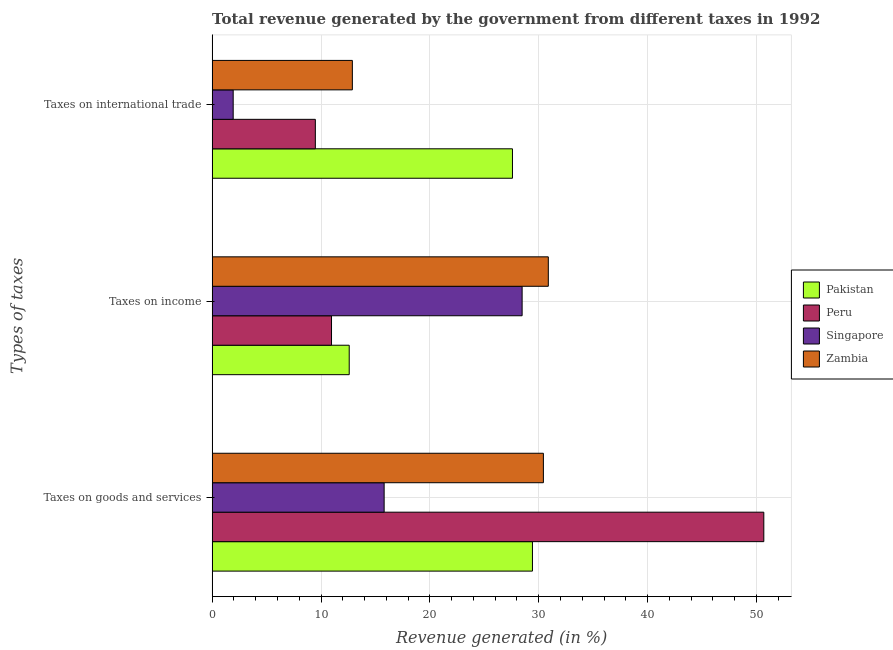How many groups of bars are there?
Your answer should be compact. 3. How many bars are there on the 1st tick from the top?
Offer a very short reply. 4. How many bars are there on the 2nd tick from the bottom?
Provide a succinct answer. 4. What is the label of the 3rd group of bars from the top?
Offer a very short reply. Taxes on goods and services. What is the percentage of revenue generated by tax on international trade in Peru?
Provide a succinct answer. 9.48. Across all countries, what is the maximum percentage of revenue generated by taxes on goods and services?
Keep it short and to the point. 50.67. Across all countries, what is the minimum percentage of revenue generated by taxes on goods and services?
Ensure brevity in your answer.  15.8. In which country was the percentage of revenue generated by taxes on goods and services minimum?
Offer a terse response. Singapore. What is the total percentage of revenue generated by tax on international trade in the graph?
Provide a short and direct response. 51.88. What is the difference between the percentage of revenue generated by taxes on income in Peru and that in Singapore?
Your answer should be compact. -17.51. What is the difference between the percentage of revenue generated by taxes on goods and services in Pakistan and the percentage of revenue generated by tax on international trade in Zambia?
Ensure brevity in your answer.  16.54. What is the average percentage of revenue generated by taxes on income per country?
Offer a very short reply. 20.73. What is the difference between the percentage of revenue generated by tax on international trade and percentage of revenue generated by taxes on goods and services in Singapore?
Your response must be concise. -13.87. What is the ratio of the percentage of revenue generated by taxes on goods and services in Singapore to that in Pakistan?
Provide a short and direct response. 0.54. What is the difference between the highest and the second highest percentage of revenue generated by taxes on goods and services?
Ensure brevity in your answer.  20.25. What is the difference between the highest and the lowest percentage of revenue generated by taxes on goods and services?
Keep it short and to the point. 34.87. In how many countries, is the percentage of revenue generated by taxes on goods and services greater than the average percentage of revenue generated by taxes on goods and services taken over all countries?
Offer a very short reply. 1. Is the sum of the percentage of revenue generated by tax on international trade in Peru and Zambia greater than the maximum percentage of revenue generated by taxes on income across all countries?
Give a very brief answer. No. Are all the bars in the graph horizontal?
Offer a terse response. Yes. Are the values on the major ticks of X-axis written in scientific E-notation?
Offer a very short reply. No. Does the graph contain any zero values?
Ensure brevity in your answer.  No. Does the graph contain grids?
Ensure brevity in your answer.  Yes. How many legend labels are there?
Your answer should be compact. 4. How are the legend labels stacked?
Provide a short and direct response. Vertical. What is the title of the graph?
Keep it short and to the point. Total revenue generated by the government from different taxes in 1992. Does "Ecuador" appear as one of the legend labels in the graph?
Make the answer very short. No. What is the label or title of the X-axis?
Provide a succinct answer. Revenue generated (in %). What is the label or title of the Y-axis?
Your answer should be compact. Types of taxes. What is the Revenue generated (in %) in Pakistan in Taxes on goods and services?
Your answer should be compact. 29.42. What is the Revenue generated (in %) of Peru in Taxes on goods and services?
Your response must be concise. 50.67. What is the Revenue generated (in %) in Singapore in Taxes on goods and services?
Provide a succinct answer. 15.8. What is the Revenue generated (in %) in Zambia in Taxes on goods and services?
Ensure brevity in your answer.  30.43. What is the Revenue generated (in %) in Pakistan in Taxes on income?
Make the answer very short. 12.59. What is the Revenue generated (in %) in Peru in Taxes on income?
Your answer should be very brief. 10.97. What is the Revenue generated (in %) of Singapore in Taxes on income?
Offer a terse response. 28.47. What is the Revenue generated (in %) of Zambia in Taxes on income?
Provide a short and direct response. 30.88. What is the Revenue generated (in %) in Pakistan in Taxes on international trade?
Provide a short and direct response. 27.59. What is the Revenue generated (in %) of Peru in Taxes on international trade?
Provide a short and direct response. 9.48. What is the Revenue generated (in %) in Singapore in Taxes on international trade?
Make the answer very short. 1.93. What is the Revenue generated (in %) in Zambia in Taxes on international trade?
Provide a succinct answer. 12.88. Across all Types of taxes, what is the maximum Revenue generated (in %) of Pakistan?
Your answer should be compact. 29.42. Across all Types of taxes, what is the maximum Revenue generated (in %) of Peru?
Offer a very short reply. 50.67. Across all Types of taxes, what is the maximum Revenue generated (in %) in Singapore?
Your answer should be very brief. 28.47. Across all Types of taxes, what is the maximum Revenue generated (in %) of Zambia?
Your response must be concise. 30.88. Across all Types of taxes, what is the minimum Revenue generated (in %) of Pakistan?
Your response must be concise. 12.59. Across all Types of taxes, what is the minimum Revenue generated (in %) in Peru?
Give a very brief answer. 9.48. Across all Types of taxes, what is the minimum Revenue generated (in %) in Singapore?
Keep it short and to the point. 1.93. Across all Types of taxes, what is the minimum Revenue generated (in %) in Zambia?
Give a very brief answer. 12.88. What is the total Revenue generated (in %) in Pakistan in the graph?
Make the answer very short. 69.6. What is the total Revenue generated (in %) in Peru in the graph?
Make the answer very short. 71.12. What is the total Revenue generated (in %) in Singapore in the graph?
Your answer should be very brief. 46.21. What is the total Revenue generated (in %) of Zambia in the graph?
Provide a succinct answer. 74.19. What is the difference between the Revenue generated (in %) in Pakistan in Taxes on goods and services and that in Taxes on income?
Make the answer very short. 16.83. What is the difference between the Revenue generated (in %) of Peru in Taxes on goods and services and that in Taxes on income?
Make the answer very short. 39.71. What is the difference between the Revenue generated (in %) of Singapore in Taxes on goods and services and that in Taxes on income?
Your answer should be compact. -12.67. What is the difference between the Revenue generated (in %) of Zambia in Taxes on goods and services and that in Taxes on income?
Offer a very short reply. -0.45. What is the difference between the Revenue generated (in %) of Pakistan in Taxes on goods and services and that in Taxes on international trade?
Your answer should be very brief. 1.84. What is the difference between the Revenue generated (in %) of Peru in Taxes on goods and services and that in Taxes on international trade?
Make the answer very short. 41.19. What is the difference between the Revenue generated (in %) in Singapore in Taxes on goods and services and that in Taxes on international trade?
Keep it short and to the point. 13.87. What is the difference between the Revenue generated (in %) of Zambia in Taxes on goods and services and that in Taxes on international trade?
Provide a short and direct response. 17.55. What is the difference between the Revenue generated (in %) in Pakistan in Taxes on income and that in Taxes on international trade?
Offer a very short reply. -14.99. What is the difference between the Revenue generated (in %) in Peru in Taxes on income and that in Taxes on international trade?
Offer a terse response. 1.49. What is the difference between the Revenue generated (in %) of Singapore in Taxes on income and that in Taxes on international trade?
Offer a terse response. 26.54. What is the difference between the Revenue generated (in %) in Zambia in Taxes on income and that in Taxes on international trade?
Offer a very short reply. 18. What is the difference between the Revenue generated (in %) in Pakistan in Taxes on goods and services and the Revenue generated (in %) in Peru in Taxes on income?
Give a very brief answer. 18.46. What is the difference between the Revenue generated (in %) of Pakistan in Taxes on goods and services and the Revenue generated (in %) of Singapore in Taxes on income?
Your answer should be compact. 0.95. What is the difference between the Revenue generated (in %) of Pakistan in Taxes on goods and services and the Revenue generated (in %) of Zambia in Taxes on income?
Keep it short and to the point. -1.46. What is the difference between the Revenue generated (in %) of Peru in Taxes on goods and services and the Revenue generated (in %) of Singapore in Taxes on income?
Ensure brevity in your answer.  22.2. What is the difference between the Revenue generated (in %) in Peru in Taxes on goods and services and the Revenue generated (in %) in Zambia in Taxes on income?
Make the answer very short. 19.79. What is the difference between the Revenue generated (in %) in Singapore in Taxes on goods and services and the Revenue generated (in %) in Zambia in Taxes on income?
Keep it short and to the point. -15.08. What is the difference between the Revenue generated (in %) in Pakistan in Taxes on goods and services and the Revenue generated (in %) in Peru in Taxes on international trade?
Offer a terse response. 19.94. What is the difference between the Revenue generated (in %) in Pakistan in Taxes on goods and services and the Revenue generated (in %) in Singapore in Taxes on international trade?
Your response must be concise. 27.49. What is the difference between the Revenue generated (in %) of Pakistan in Taxes on goods and services and the Revenue generated (in %) of Zambia in Taxes on international trade?
Ensure brevity in your answer.  16.54. What is the difference between the Revenue generated (in %) in Peru in Taxes on goods and services and the Revenue generated (in %) in Singapore in Taxes on international trade?
Make the answer very short. 48.74. What is the difference between the Revenue generated (in %) of Peru in Taxes on goods and services and the Revenue generated (in %) of Zambia in Taxes on international trade?
Keep it short and to the point. 37.79. What is the difference between the Revenue generated (in %) of Singapore in Taxes on goods and services and the Revenue generated (in %) of Zambia in Taxes on international trade?
Your response must be concise. 2.92. What is the difference between the Revenue generated (in %) in Pakistan in Taxes on income and the Revenue generated (in %) in Peru in Taxes on international trade?
Offer a terse response. 3.11. What is the difference between the Revenue generated (in %) in Pakistan in Taxes on income and the Revenue generated (in %) in Singapore in Taxes on international trade?
Your response must be concise. 10.66. What is the difference between the Revenue generated (in %) in Pakistan in Taxes on income and the Revenue generated (in %) in Zambia in Taxes on international trade?
Ensure brevity in your answer.  -0.29. What is the difference between the Revenue generated (in %) in Peru in Taxes on income and the Revenue generated (in %) in Singapore in Taxes on international trade?
Keep it short and to the point. 9.03. What is the difference between the Revenue generated (in %) in Peru in Taxes on income and the Revenue generated (in %) in Zambia in Taxes on international trade?
Give a very brief answer. -1.92. What is the difference between the Revenue generated (in %) in Singapore in Taxes on income and the Revenue generated (in %) in Zambia in Taxes on international trade?
Offer a terse response. 15.59. What is the average Revenue generated (in %) of Pakistan per Types of taxes?
Provide a short and direct response. 23.2. What is the average Revenue generated (in %) in Peru per Types of taxes?
Make the answer very short. 23.71. What is the average Revenue generated (in %) of Singapore per Types of taxes?
Offer a terse response. 15.4. What is the average Revenue generated (in %) in Zambia per Types of taxes?
Your answer should be very brief. 24.73. What is the difference between the Revenue generated (in %) in Pakistan and Revenue generated (in %) in Peru in Taxes on goods and services?
Offer a terse response. -21.25. What is the difference between the Revenue generated (in %) in Pakistan and Revenue generated (in %) in Singapore in Taxes on goods and services?
Give a very brief answer. 13.62. What is the difference between the Revenue generated (in %) of Pakistan and Revenue generated (in %) of Zambia in Taxes on goods and services?
Offer a terse response. -1. What is the difference between the Revenue generated (in %) of Peru and Revenue generated (in %) of Singapore in Taxes on goods and services?
Provide a succinct answer. 34.87. What is the difference between the Revenue generated (in %) in Peru and Revenue generated (in %) in Zambia in Taxes on goods and services?
Make the answer very short. 20.25. What is the difference between the Revenue generated (in %) of Singapore and Revenue generated (in %) of Zambia in Taxes on goods and services?
Offer a terse response. -14.63. What is the difference between the Revenue generated (in %) in Pakistan and Revenue generated (in %) in Peru in Taxes on income?
Keep it short and to the point. 1.63. What is the difference between the Revenue generated (in %) in Pakistan and Revenue generated (in %) in Singapore in Taxes on income?
Offer a terse response. -15.88. What is the difference between the Revenue generated (in %) of Pakistan and Revenue generated (in %) of Zambia in Taxes on income?
Your response must be concise. -18.29. What is the difference between the Revenue generated (in %) in Peru and Revenue generated (in %) in Singapore in Taxes on income?
Your response must be concise. -17.51. What is the difference between the Revenue generated (in %) in Peru and Revenue generated (in %) in Zambia in Taxes on income?
Make the answer very short. -19.91. What is the difference between the Revenue generated (in %) in Singapore and Revenue generated (in %) in Zambia in Taxes on income?
Provide a short and direct response. -2.41. What is the difference between the Revenue generated (in %) of Pakistan and Revenue generated (in %) of Peru in Taxes on international trade?
Provide a short and direct response. 18.11. What is the difference between the Revenue generated (in %) in Pakistan and Revenue generated (in %) in Singapore in Taxes on international trade?
Provide a succinct answer. 25.65. What is the difference between the Revenue generated (in %) of Pakistan and Revenue generated (in %) of Zambia in Taxes on international trade?
Offer a terse response. 14.71. What is the difference between the Revenue generated (in %) in Peru and Revenue generated (in %) in Singapore in Taxes on international trade?
Make the answer very short. 7.55. What is the difference between the Revenue generated (in %) in Peru and Revenue generated (in %) in Zambia in Taxes on international trade?
Your answer should be compact. -3.4. What is the difference between the Revenue generated (in %) in Singapore and Revenue generated (in %) in Zambia in Taxes on international trade?
Keep it short and to the point. -10.95. What is the ratio of the Revenue generated (in %) of Pakistan in Taxes on goods and services to that in Taxes on income?
Provide a short and direct response. 2.34. What is the ratio of the Revenue generated (in %) in Peru in Taxes on goods and services to that in Taxes on income?
Your response must be concise. 4.62. What is the ratio of the Revenue generated (in %) of Singapore in Taxes on goods and services to that in Taxes on income?
Keep it short and to the point. 0.55. What is the ratio of the Revenue generated (in %) of Zambia in Taxes on goods and services to that in Taxes on income?
Make the answer very short. 0.99. What is the ratio of the Revenue generated (in %) in Pakistan in Taxes on goods and services to that in Taxes on international trade?
Keep it short and to the point. 1.07. What is the ratio of the Revenue generated (in %) of Peru in Taxes on goods and services to that in Taxes on international trade?
Offer a terse response. 5.34. What is the ratio of the Revenue generated (in %) of Singapore in Taxes on goods and services to that in Taxes on international trade?
Keep it short and to the point. 8.17. What is the ratio of the Revenue generated (in %) of Zambia in Taxes on goods and services to that in Taxes on international trade?
Make the answer very short. 2.36. What is the ratio of the Revenue generated (in %) of Pakistan in Taxes on income to that in Taxes on international trade?
Offer a terse response. 0.46. What is the ratio of the Revenue generated (in %) of Peru in Taxes on income to that in Taxes on international trade?
Give a very brief answer. 1.16. What is the ratio of the Revenue generated (in %) of Singapore in Taxes on income to that in Taxes on international trade?
Offer a very short reply. 14.72. What is the ratio of the Revenue generated (in %) in Zambia in Taxes on income to that in Taxes on international trade?
Provide a short and direct response. 2.4. What is the difference between the highest and the second highest Revenue generated (in %) in Pakistan?
Your answer should be compact. 1.84. What is the difference between the highest and the second highest Revenue generated (in %) in Peru?
Provide a succinct answer. 39.71. What is the difference between the highest and the second highest Revenue generated (in %) in Singapore?
Keep it short and to the point. 12.67. What is the difference between the highest and the second highest Revenue generated (in %) of Zambia?
Your answer should be very brief. 0.45. What is the difference between the highest and the lowest Revenue generated (in %) of Pakistan?
Ensure brevity in your answer.  16.83. What is the difference between the highest and the lowest Revenue generated (in %) of Peru?
Offer a terse response. 41.19. What is the difference between the highest and the lowest Revenue generated (in %) in Singapore?
Provide a succinct answer. 26.54. What is the difference between the highest and the lowest Revenue generated (in %) in Zambia?
Offer a terse response. 18. 